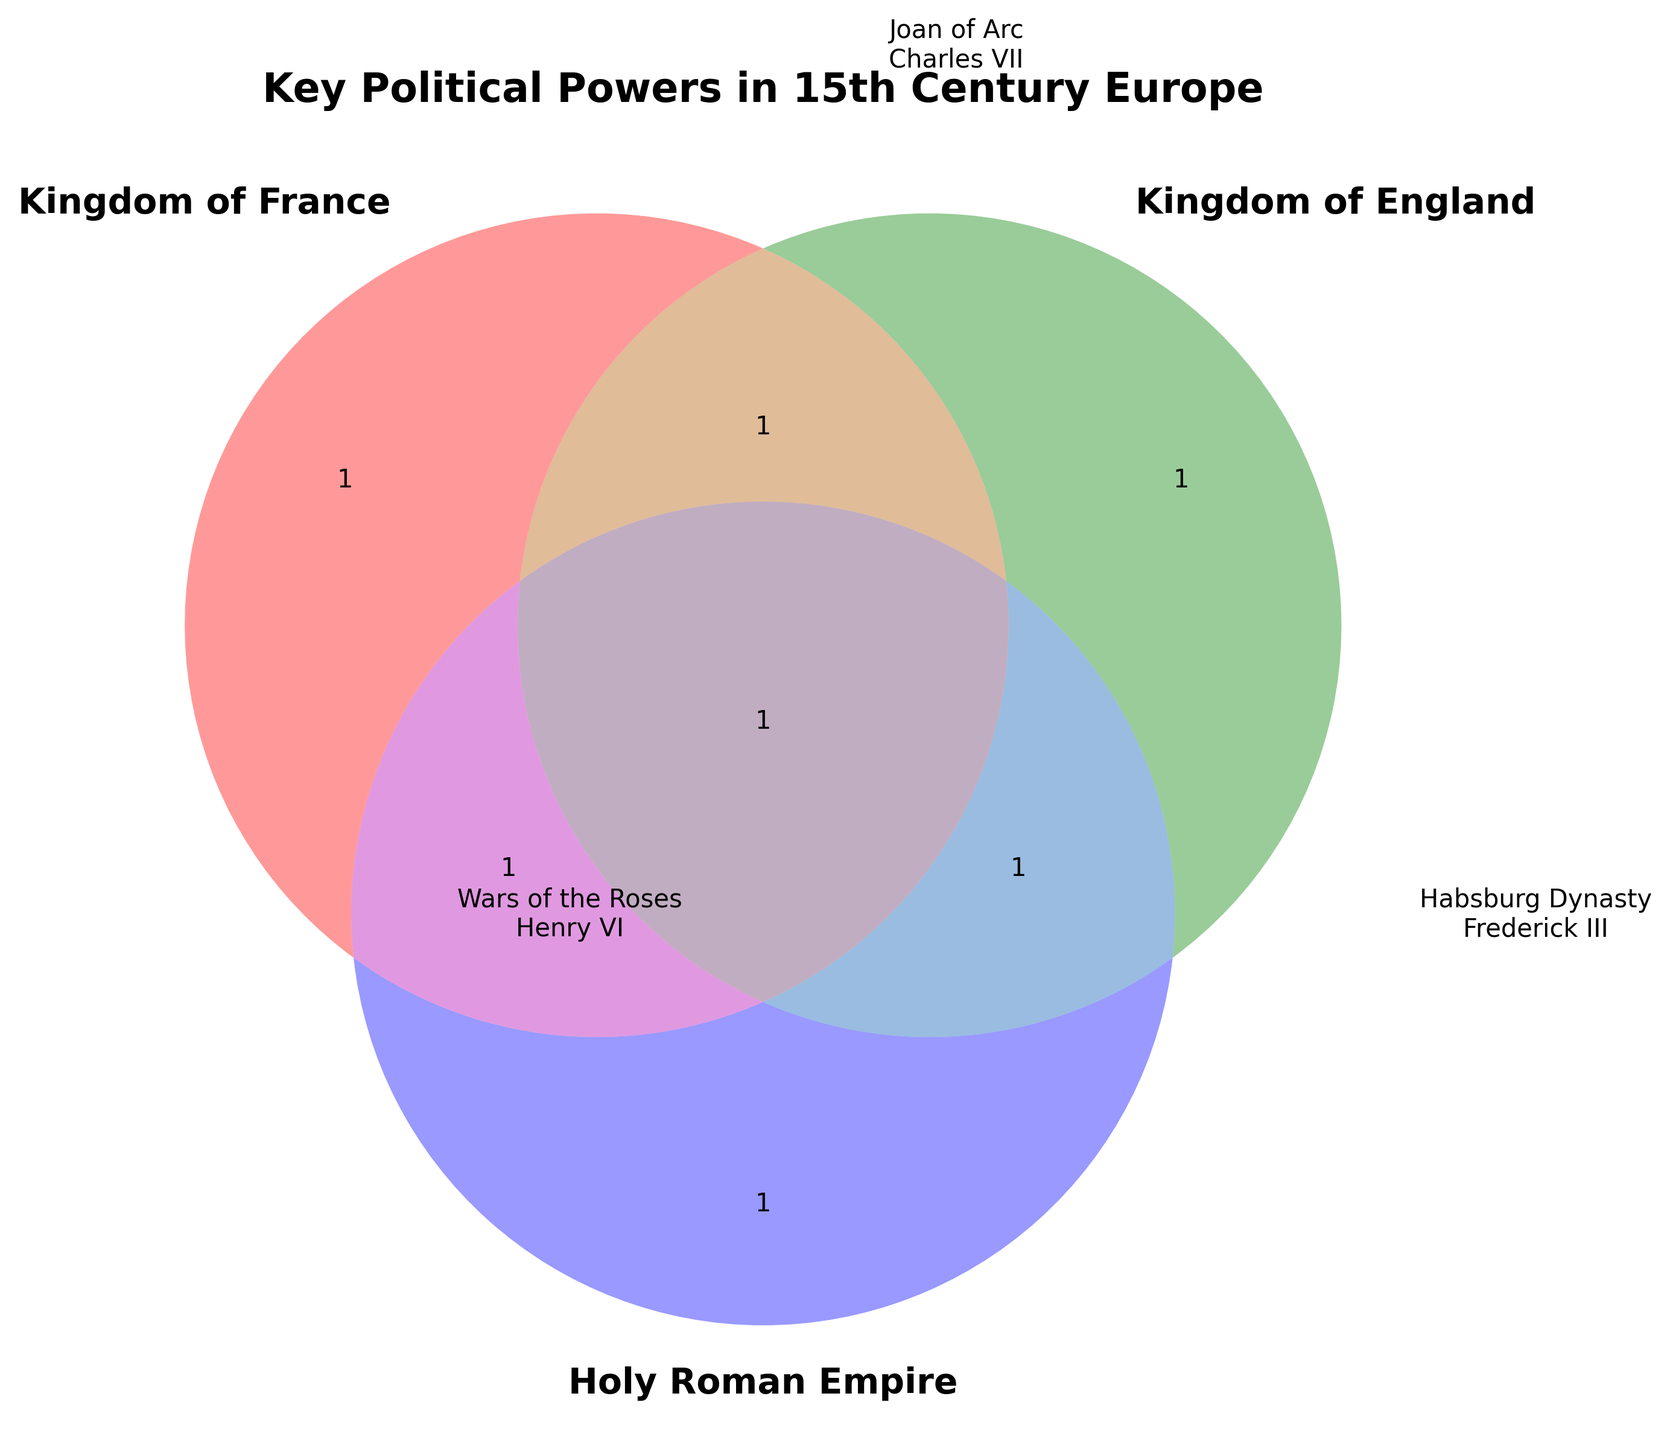What is the title of the figure? The title is the text displayed at the top of the figure. It reads "Key Political Powers in 15th Century Europe".
Answer: Key Political Powers in 15th Century Europe Which political power is associated with the "Wars of the Roses"? The text "Wars of the Roses" is located outside the circle labeled "Holy Roman Empire" and is associated with "Kingdom of England."
Answer: Kingdom of England List the key elements associated with the Kingdom of France. The key elements inside or near the circle labeled "Kingdom of France" include "Joan of Arc" and "Charles VII".
Answer: Joan of Arc, Charles VII What are the shared political elements between the Kingdom of England and the Holy Roman Empire? By examining the overlapping areas, the shared elements between the "Kingdom of England" and the "Holy Roman Empire" can be identified. However, from the figure, it appears that there is no marked overlap shared between the Kingdom of England and the Holy Roman Empire.
Answer: None Compare the political figures of the Kingdom of France and the Holy Roman Empire. The political figures for the Kingdom of France are "Joan of Arc" and "Charles VII"; for the Holy Roman Empire, they are "Habsburg Dynasty" and "Frederick III".
Answer: Joan of Arc, Charles VII vs. Habsburg Dynasty, Frederick III Which regions are associated with key political elements of the Kingdom of England? The text outside the circle labeled "Kingdom of England" includes regions like "Calais" and "English Channel".
Answer: Calais, English Channel Identify which house is connected to the Kingdom of England in the figure. The text mentioning houses associated with the Kingdom of England includes "House of Lancaster" and "House of York" shown outside the corresponding circle.
Answer: House of Lancaster, House of York What element is associated with the governance of the Holy Roman Empire? The text inside the Holy Roman Empire's circle contains "Imperial Diet" and "Electors," which are elements of governance.
Answer: Imperial Diet, Electors List the rulers associated with each political power. The figure lists "Charles VII" under the Kingdom of France, "Henry VI" under the Kingdom of England, and "Frederick III" under the Holy Roman Empire.
Answer: Charles VII, Henry VI, Frederick III How many regions are associated with the Holy Roman Empire? Count the regions listed near the Holy Roman Empire, which include "Bohemia" and "Switzerland". There are two regions.
Answer: 2 